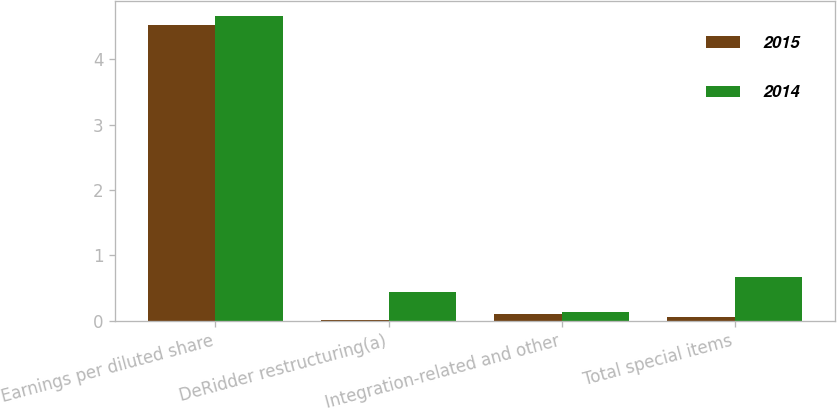<chart> <loc_0><loc_0><loc_500><loc_500><stacked_bar_chart><ecel><fcel>Earnings per diluted share<fcel>DeRidder restructuring(a)<fcel>Integration-related and other<fcel>Total special items<nl><fcel>2015<fcel>4.53<fcel>0.01<fcel>0.1<fcel>0.06<nl><fcel>2014<fcel>4.66<fcel>0.43<fcel>0.13<fcel>0.67<nl></chart> 